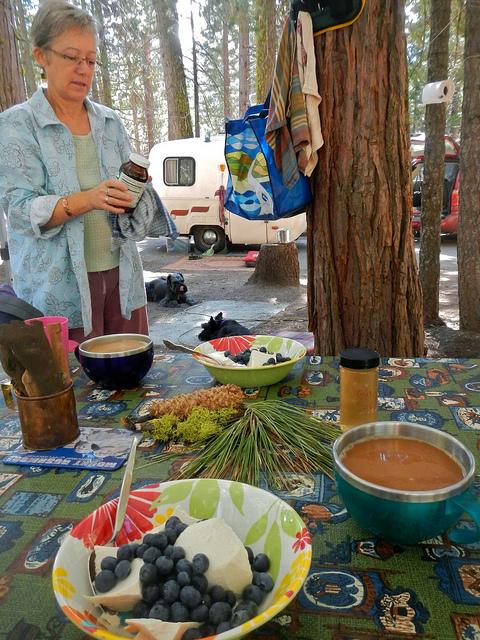Are the foods on the table healthy?
Answer briefly. Yes. How many bowls are there?
Write a very short answer. 4. What kind of vehicle is in the background?
Answer briefly. Camper. 